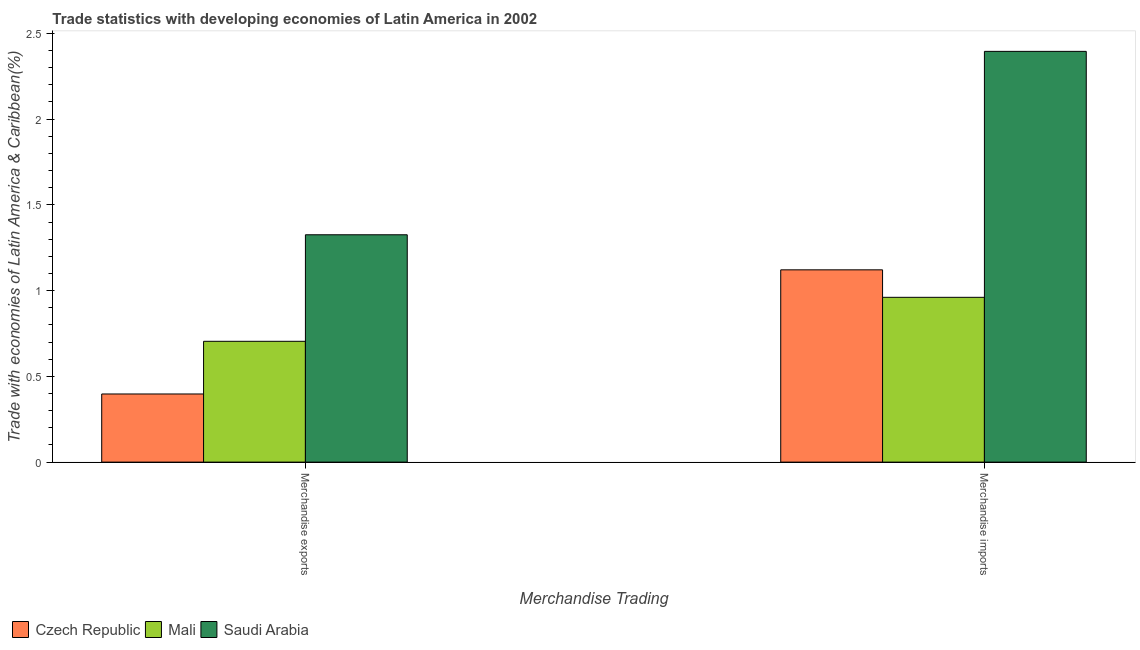How many groups of bars are there?
Ensure brevity in your answer.  2. Are the number of bars per tick equal to the number of legend labels?
Make the answer very short. Yes. How many bars are there on the 2nd tick from the right?
Your answer should be compact. 3. What is the merchandise exports in Mali?
Offer a terse response. 0.7. Across all countries, what is the maximum merchandise imports?
Your answer should be compact. 2.4. Across all countries, what is the minimum merchandise imports?
Your answer should be very brief. 0.96. In which country was the merchandise exports maximum?
Ensure brevity in your answer.  Saudi Arabia. In which country was the merchandise exports minimum?
Offer a very short reply. Czech Republic. What is the total merchandise imports in the graph?
Your answer should be very brief. 4.48. What is the difference between the merchandise imports in Mali and that in Czech Republic?
Keep it short and to the point. -0.16. What is the difference between the merchandise imports in Czech Republic and the merchandise exports in Mali?
Your answer should be compact. 0.42. What is the average merchandise exports per country?
Offer a terse response. 0.81. What is the difference between the merchandise exports and merchandise imports in Saudi Arabia?
Offer a very short reply. -1.07. In how many countries, is the merchandise imports greater than 2.4 %?
Offer a very short reply. 0. What is the ratio of the merchandise exports in Mali to that in Saudi Arabia?
Provide a succinct answer. 0.53. In how many countries, is the merchandise imports greater than the average merchandise imports taken over all countries?
Offer a terse response. 1. What does the 2nd bar from the left in Merchandise imports represents?
Keep it short and to the point. Mali. What does the 2nd bar from the right in Merchandise imports represents?
Provide a succinct answer. Mali. Does the graph contain any zero values?
Your response must be concise. No. Does the graph contain grids?
Provide a succinct answer. No. How many legend labels are there?
Ensure brevity in your answer.  3. How are the legend labels stacked?
Provide a short and direct response. Horizontal. What is the title of the graph?
Offer a terse response. Trade statistics with developing economies of Latin America in 2002. Does "Bermuda" appear as one of the legend labels in the graph?
Make the answer very short. No. What is the label or title of the X-axis?
Provide a succinct answer. Merchandise Trading. What is the label or title of the Y-axis?
Make the answer very short. Trade with economies of Latin America & Caribbean(%). What is the Trade with economies of Latin America & Caribbean(%) in Czech Republic in Merchandise exports?
Ensure brevity in your answer.  0.4. What is the Trade with economies of Latin America & Caribbean(%) of Mali in Merchandise exports?
Provide a succinct answer. 0.7. What is the Trade with economies of Latin America & Caribbean(%) in Saudi Arabia in Merchandise exports?
Make the answer very short. 1.33. What is the Trade with economies of Latin America & Caribbean(%) of Czech Republic in Merchandise imports?
Provide a short and direct response. 1.12. What is the Trade with economies of Latin America & Caribbean(%) in Mali in Merchandise imports?
Your answer should be very brief. 0.96. What is the Trade with economies of Latin America & Caribbean(%) in Saudi Arabia in Merchandise imports?
Your answer should be compact. 2.4. Across all Merchandise Trading, what is the maximum Trade with economies of Latin America & Caribbean(%) of Czech Republic?
Keep it short and to the point. 1.12. Across all Merchandise Trading, what is the maximum Trade with economies of Latin America & Caribbean(%) of Mali?
Ensure brevity in your answer.  0.96. Across all Merchandise Trading, what is the maximum Trade with economies of Latin America & Caribbean(%) in Saudi Arabia?
Your answer should be compact. 2.4. Across all Merchandise Trading, what is the minimum Trade with economies of Latin America & Caribbean(%) in Czech Republic?
Provide a succinct answer. 0.4. Across all Merchandise Trading, what is the minimum Trade with economies of Latin America & Caribbean(%) in Mali?
Your answer should be very brief. 0.7. Across all Merchandise Trading, what is the minimum Trade with economies of Latin America & Caribbean(%) in Saudi Arabia?
Give a very brief answer. 1.33. What is the total Trade with economies of Latin America & Caribbean(%) of Czech Republic in the graph?
Give a very brief answer. 1.52. What is the total Trade with economies of Latin America & Caribbean(%) in Mali in the graph?
Ensure brevity in your answer.  1.67. What is the total Trade with economies of Latin America & Caribbean(%) of Saudi Arabia in the graph?
Keep it short and to the point. 3.72. What is the difference between the Trade with economies of Latin America & Caribbean(%) in Czech Republic in Merchandise exports and that in Merchandise imports?
Ensure brevity in your answer.  -0.72. What is the difference between the Trade with economies of Latin America & Caribbean(%) in Mali in Merchandise exports and that in Merchandise imports?
Offer a terse response. -0.26. What is the difference between the Trade with economies of Latin America & Caribbean(%) of Saudi Arabia in Merchandise exports and that in Merchandise imports?
Make the answer very short. -1.07. What is the difference between the Trade with economies of Latin America & Caribbean(%) of Czech Republic in Merchandise exports and the Trade with economies of Latin America & Caribbean(%) of Mali in Merchandise imports?
Provide a succinct answer. -0.56. What is the difference between the Trade with economies of Latin America & Caribbean(%) of Czech Republic in Merchandise exports and the Trade with economies of Latin America & Caribbean(%) of Saudi Arabia in Merchandise imports?
Provide a succinct answer. -2. What is the difference between the Trade with economies of Latin America & Caribbean(%) in Mali in Merchandise exports and the Trade with economies of Latin America & Caribbean(%) in Saudi Arabia in Merchandise imports?
Make the answer very short. -1.69. What is the average Trade with economies of Latin America & Caribbean(%) of Czech Republic per Merchandise Trading?
Provide a short and direct response. 0.76. What is the average Trade with economies of Latin America & Caribbean(%) in Mali per Merchandise Trading?
Provide a short and direct response. 0.83. What is the average Trade with economies of Latin America & Caribbean(%) in Saudi Arabia per Merchandise Trading?
Your answer should be very brief. 1.86. What is the difference between the Trade with economies of Latin America & Caribbean(%) of Czech Republic and Trade with economies of Latin America & Caribbean(%) of Mali in Merchandise exports?
Ensure brevity in your answer.  -0.31. What is the difference between the Trade with economies of Latin America & Caribbean(%) in Czech Republic and Trade with economies of Latin America & Caribbean(%) in Saudi Arabia in Merchandise exports?
Make the answer very short. -0.93. What is the difference between the Trade with economies of Latin America & Caribbean(%) of Mali and Trade with economies of Latin America & Caribbean(%) of Saudi Arabia in Merchandise exports?
Your answer should be compact. -0.62. What is the difference between the Trade with economies of Latin America & Caribbean(%) of Czech Republic and Trade with economies of Latin America & Caribbean(%) of Mali in Merchandise imports?
Your response must be concise. 0.16. What is the difference between the Trade with economies of Latin America & Caribbean(%) of Czech Republic and Trade with economies of Latin America & Caribbean(%) of Saudi Arabia in Merchandise imports?
Provide a succinct answer. -1.27. What is the difference between the Trade with economies of Latin America & Caribbean(%) in Mali and Trade with economies of Latin America & Caribbean(%) in Saudi Arabia in Merchandise imports?
Your response must be concise. -1.43. What is the ratio of the Trade with economies of Latin America & Caribbean(%) of Czech Republic in Merchandise exports to that in Merchandise imports?
Your response must be concise. 0.35. What is the ratio of the Trade with economies of Latin America & Caribbean(%) of Mali in Merchandise exports to that in Merchandise imports?
Make the answer very short. 0.73. What is the ratio of the Trade with economies of Latin America & Caribbean(%) in Saudi Arabia in Merchandise exports to that in Merchandise imports?
Your response must be concise. 0.55. What is the difference between the highest and the second highest Trade with economies of Latin America & Caribbean(%) in Czech Republic?
Provide a short and direct response. 0.72. What is the difference between the highest and the second highest Trade with economies of Latin America & Caribbean(%) in Mali?
Your answer should be compact. 0.26. What is the difference between the highest and the second highest Trade with economies of Latin America & Caribbean(%) of Saudi Arabia?
Your answer should be compact. 1.07. What is the difference between the highest and the lowest Trade with economies of Latin America & Caribbean(%) of Czech Republic?
Your answer should be very brief. 0.72. What is the difference between the highest and the lowest Trade with economies of Latin America & Caribbean(%) of Mali?
Offer a terse response. 0.26. What is the difference between the highest and the lowest Trade with economies of Latin America & Caribbean(%) of Saudi Arabia?
Make the answer very short. 1.07. 